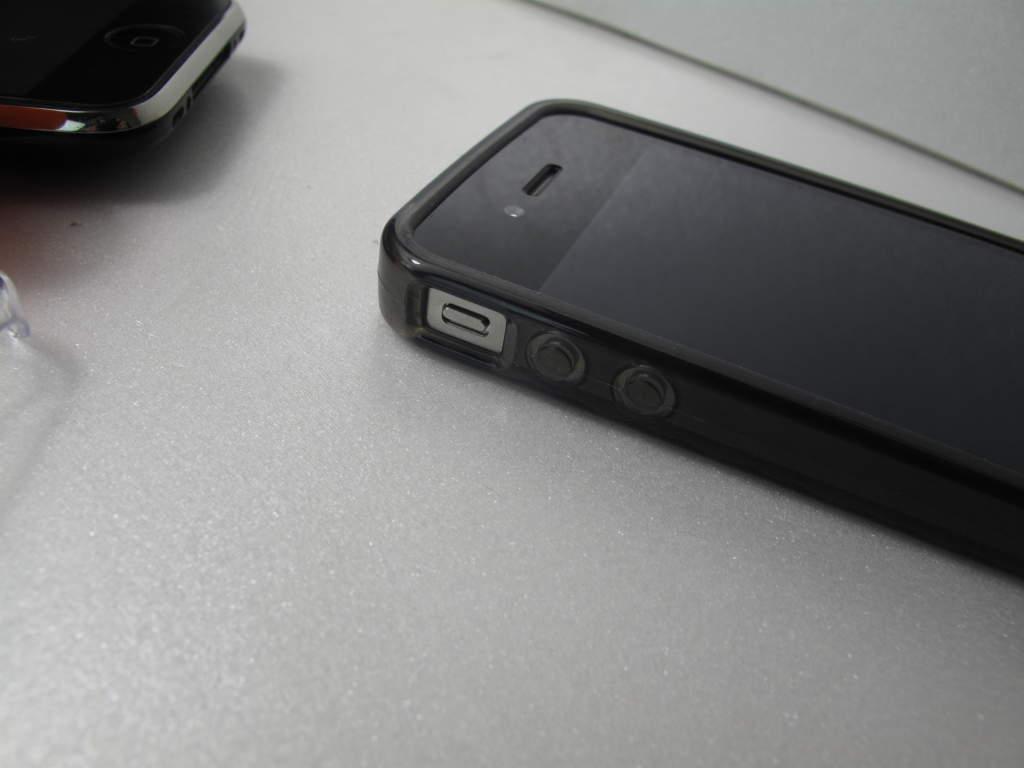Please provide a concise description of this image. In this image I can see two black colour phones. I can also see one more thing over here. 